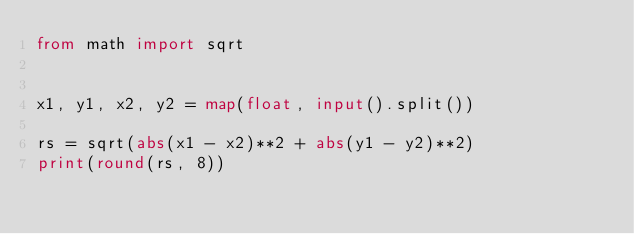<code> <loc_0><loc_0><loc_500><loc_500><_Python_>from math import sqrt


x1, y1, x2, y2 = map(float, input().split())

rs = sqrt(abs(x1 - x2)**2 + abs(y1 - y2)**2)
print(round(rs, 8))
</code> 